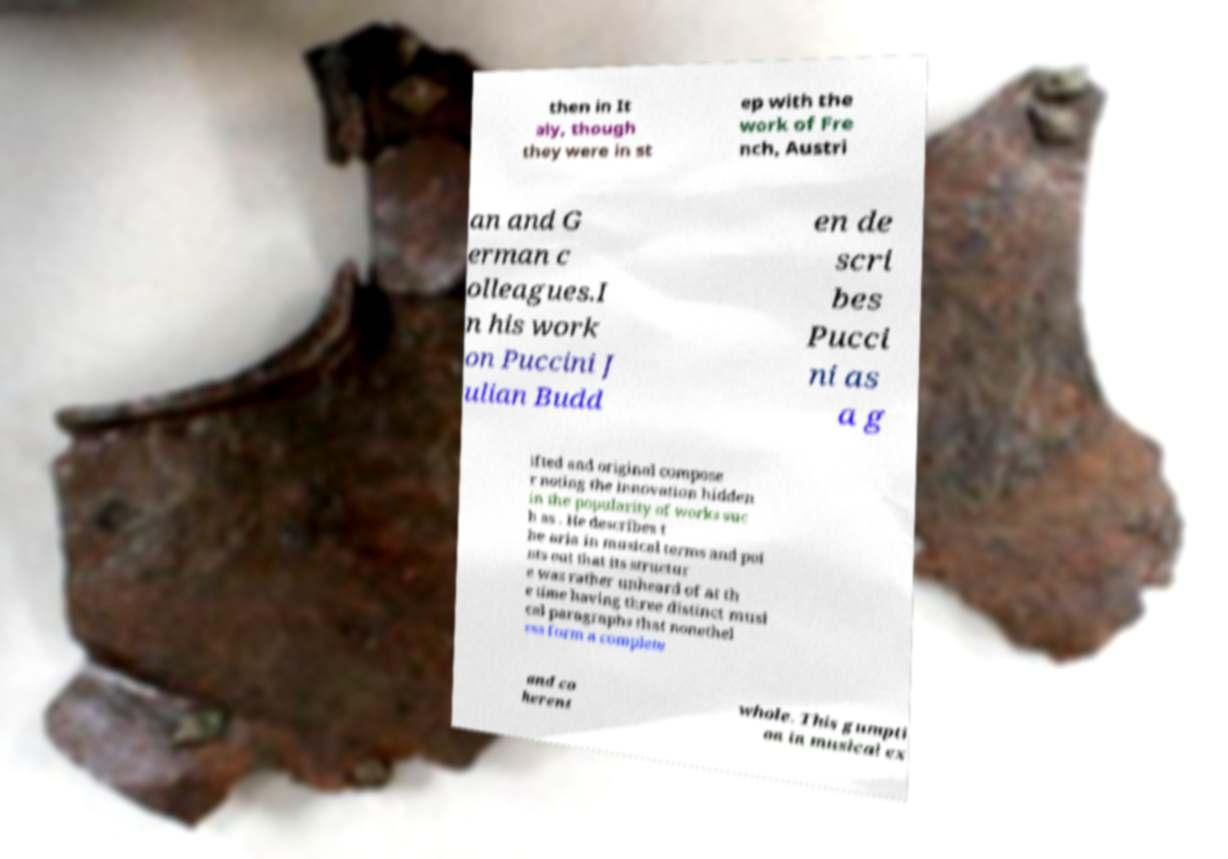What messages or text are displayed in this image? I need them in a readable, typed format. then in It aly, though they were in st ep with the work of Fre nch, Austri an and G erman c olleagues.I n his work on Puccini J ulian Budd en de scri bes Pucci ni as a g ifted and original compose r noting the innovation hidden in the popularity of works suc h as . He describes t he aria in musical terms and poi nts out that its structur e was rather unheard of at th e time having three distinct musi cal paragraphs that nonethel ess form a complete and co herent whole. This gumpti on in musical ex 